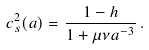<formula> <loc_0><loc_0><loc_500><loc_500>c _ { s } ^ { 2 } ( a ) = \frac { 1 - h } { 1 + \mu \nu a ^ { - 3 } } \, .</formula> 